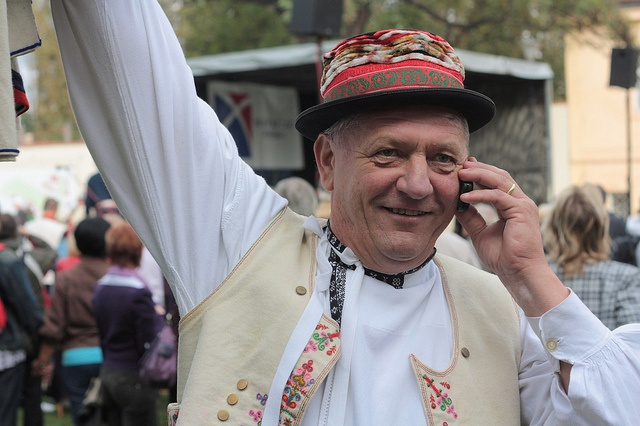Describe the objects in this image and their specific colors. I can see people in darkgray, lavender, and gray tones, people in darkgray, black, and gray tones, people in darkgray, black, brown, and teal tones, people in darkgray, gray, and black tones, and people in darkgray, black, gray, blue, and darkblue tones in this image. 